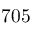Convert formula to latex. <formula><loc_0><loc_0><loc_500><loc_500>7 0 5</formula> 